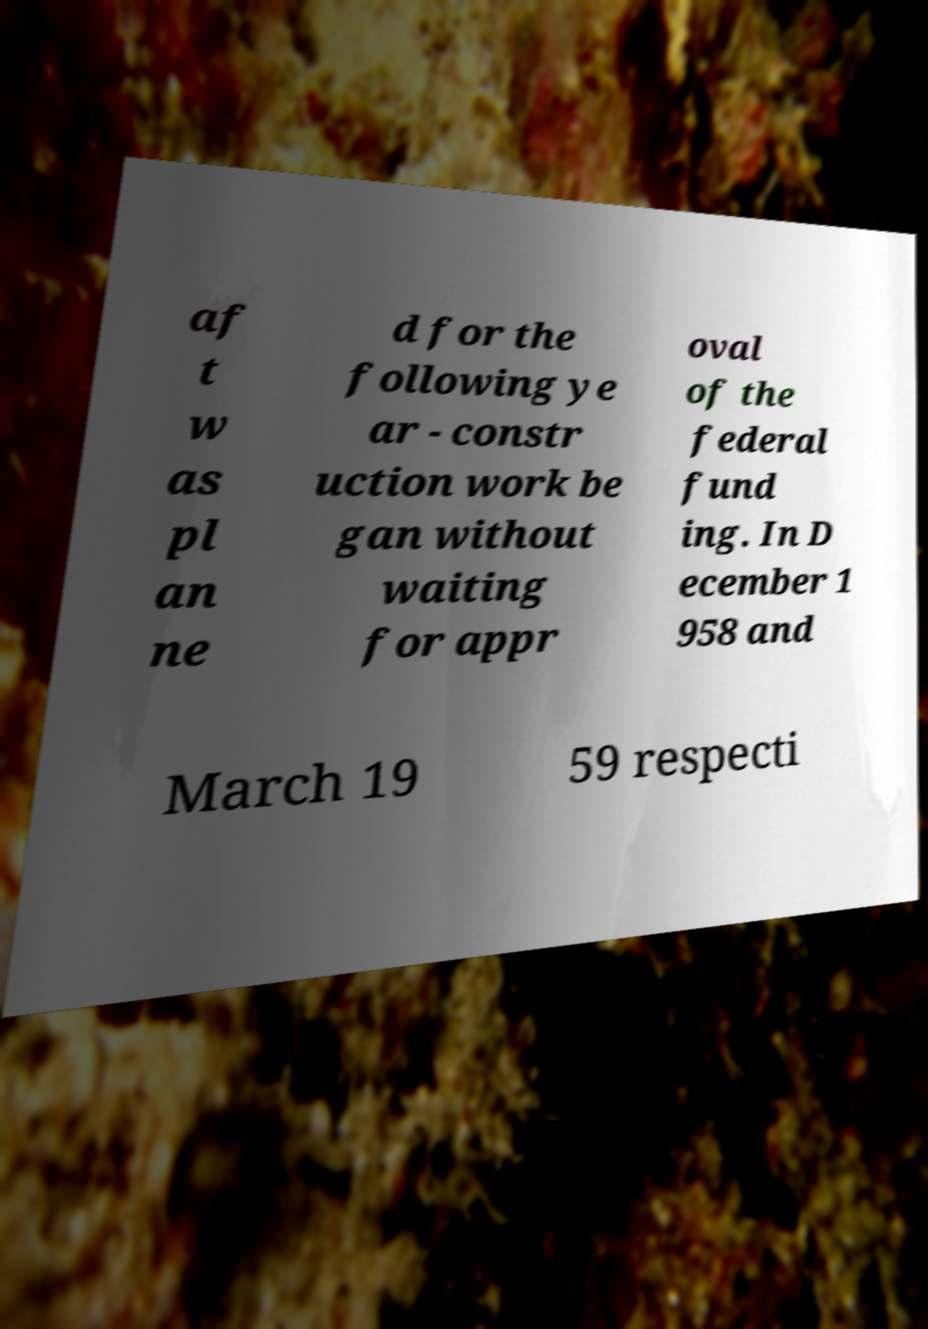Could you extract and type out the text from this image? af t w as pl an ne d for the following ye ar - constr uction work be gan without waiting for appr oval of the federal fund ing. In D ecember 1 958 and March 19 59 respecti 